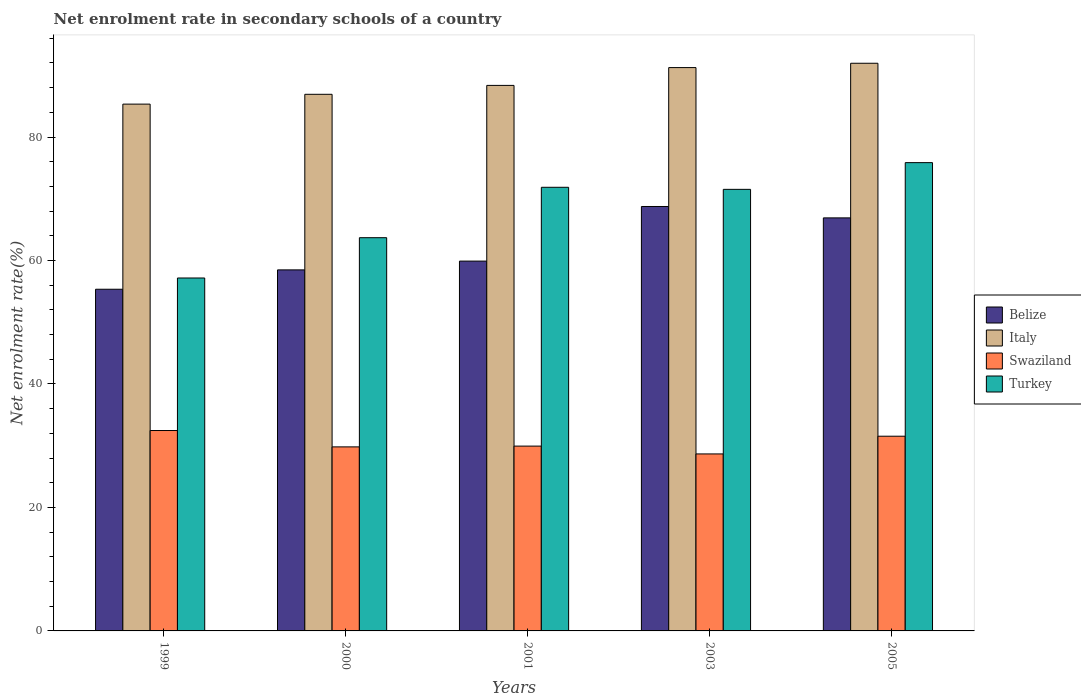How many different coloured bars are there?
Your answer should be very brief. 4. Are the number of bars on each tick of the X-axis equal?
Provide a succinct answer. Yes. How many bars are there on the 4th tick from the right?
Ensure brevity in your answer.  4. What is the label of the 5th group of bars from the left?
Offer a terse response. 2005. What is the net enrolment rate in secondary schools in Swaziland in 1999?
Offer a terse response. 32.46. Across all years, what is the maximum net enrolment rate in secondary schools in Italy?
Provide a succinct answer. 91.95. Across all years, what is the minimum net enrolment rate in secondary schools in Turkey?
Your answer should be compact. 57.17. What is the total net enrolment rate in secondary schools in Turkey in the graph?
Give a very brief answer. 340.11. What is the difference between the net enrolment rate in secondary schools in Swaziland in 1999 and that in 2003?
Offer a very short reply. 3.79. What is the difference between the net enrolment rate in secondary schools in Swaziland in 2000 and the net enrolment rate in secondary schools in Turkey in 2005?
Keep it short and to the point. -46.04. What is the average net enrolment rate in secondary schools in Turkey per year?
Give a very brief answer. 68.02. In the year 2001, what is the difference between the net enrolment rate in secondary schools in Belize and net enrolment rate in secondary schools in Swaziland?
Ensure brevity in your answer.  29.97. What is the ratio of the net enrolment rate in secondary schools in Belize in 1999 to that in 2001?
Provide a succinct answer. 0.92. Is the difference between the net enrolment rate in secondary schools in Belize in 1999 and 2001 greater than the difference between the net enrolment rate in secondary schools in Swaziland in 1999 and 2001?
Offer a very short reply. No. What is the difference between the highest and the second highest net enrolment rate in secondary schools in Turkey?
Offer a terse response. 3.99. What is the difference between the highest and the lowest net enrolment rate in secondary schools in Swaziland?
Your response must be concise. 3.79. Is it the case that in every year, the sum of the net enrolment rate in secondary schools in Swaziland and net enrolment rate in secondary schools in Belize is greater than the sum of net enrolment rate in secondary schools in Turkey and net enrolment rate in secondary schools in Italy?
Your answer should be compact. Yes. What does the 1st bar from the left in 2000 represents?
Offer a very short reply. Belize. What does the 1st bar from the right in 2003 represents?
Give a very brief answer. Turkey. How many bars are there?
Your answer should be compact. 20. Are all the bars in the graph horizontal?
Make the answer very short. No. What is the difference between two consecutive major ticks on the Y-axis?
Your answer should be very brief. 20. Does the graph contain any zero values?
Ensure brevity in your answer.  No. Does the graph contain grids?
Make the answer very short. No. Where does the legend appear in the graph?
Make the answer very short. Center right. How many legend labels are there?
Offer a very short reply. 4. What is the title of the graph?
Keep it short and to the point. Net enrolment rate in secondary schools of a country. What is the label or title of the Y-axis?
Make the answer very short. Net enrolment rate(%). What is the Net enrolment rate(%) of Belize in 1999?
Offer a terse response. 55.35. What is the Net enrolment rate(%) of Italy in 1999?
Your response must be concise. 85.33. What is the Net enrolment rate(%) of Swaziland in 1999?
Offer a terse response. 32.46. What is the Net enrolment rate(%) of Turkey in 1999?
Ensure brevity in your answer.  57.17. What is the Net enrolment rate(%) in Belize in 2000?
Offer a very short reply. 58.48. What is the Net enrolment rate(%) of Italy in 2000?
Offer a very short reply. 86.92. What is the Net enrolment rate(%) of Swaziland in 2000?
Give a very brief answer. 29.81. What is the Net enrolment rate(%) in Turkey in 2000?
Provide a succinct answer. 63.7. What is the Net enrolment rate(%) in Belize in 2001?
Keep it short and to the point. 59.9. What is the Net enrolment rate(%) in Italy in 2001?
Give a very brief answer. 88.37. What is the Net enrolment rate(%) in Swaziland in 2001?
Offer a terse response. 29.94. What is the Net enrolment rate(%) of Turkey in 2001?
Your response must be concise. 71.86. What is the Net enrolment rate(%) in Belize in 2003?
Your answer should be very brief. 68.75. What is the Net enrolment rate(%) in Italy in 2003?
Keep it short and to the point. 91.25. What is the Net enrolment rate(%) in Swaziland in 2003?
Provide a succinct answer. 28.67. What is the Net enrolment rate(%) of Turkey in 2003?
Provide a short and direct response. 71.53. What is the Net enrolment rate(%) of Belize in 2005?
Provide a succinct answer. 66.91. What is the Net enrolment rate(%) of Italy in 2005?
Provide a succinct answer. 91.95. What is the Net enrolment rate(%) of Swaziland in 2005?
Your answer should be compact. 31.54. What is the Net enrolment rate(%) of Turkey in 2005?
Ensure brevity in your answer.  75.85. Across all years, what is the maximum Net enrolment rate(%) of Belize?
Ensure brevity in your answer.  68.75. Across all years, what is the maximum Net enrolment rate(%) of Italy?
Your answer should be very brief. 91.95. Across all years, what is the maximum Net enrolment rate(%) in Swaziland?
Offer a very short reply. 32.46. Across all years, what is the maximum Net enrolment rate(%) of Turkey?
Your response must be concise. 75.85. Across all years, what is the minimum Net enrolment rate(%) in Belize?
Make the answer very short. 55.35. Across all years, what is the minimum Net enrolment rate(%) in Italy?
Give a very brief answer. 85.33. Across all years, what is the minimum Net enrolment rate(%) of Swaziland?
Ensure brevity in your answer.  28.67. Across all years, what is the minimum Net enrolment rate(%) in Turkey?
Offer a terse response. 57.17. What is the total Net enrolment rate(%) of Belize in the graph?
Keep it short and to the point. 309.39. What is the total Net enrolment rate(%) in Italy in the graph?
Give a very brief answer. 443.82. What is the total Net enrolment rate(%) in Swaziland in the graph?
Offer a very short reply. 152.42. What is the total Net enrolment rate(%) in Turkey in the graph?
Keep it short and to the point. 340.11. What is the difference between the Net enrolment rate(%) in Belize in 1999 and that in 2000?
Offer a very short reply. -3.14. What is the difference between the Net enrolment rate(%) in Italy in 1999 and that in 2000?
Ensure brevity in your answer.  -1.59. What is the difference between the Net enrolment rate(%) of Swaziland in 1999 and that in 2000?
Offer a very short reply. 2.65. What is the difference between the Net enrolment rate(%) of Turkey in 1999 and that in 2000?
Provide a succinct answer. -6.53. What is the difference between the Net enrolment rate(%) of Belize in 1999 and that in 2001?
Provide a short and direct response. -4.56. What is the difference between the Net enrolment rate(%) in Italy in 1999 and that in 2001?
Keep it short and to the point. -3.03. What is the difference between the Net enrolment rate(%) of Swaziland in 1999 and that in 2001?
Keep it short and to the point. 2.52. What is the difference between the Net enrolment rate(%) in Turkey in 1999 and that in 2001?
Your answer should be compact. -14.69. What is the difference between the Net enrolment rate(%) in Belize in 1999 and that in 2003?
Make the answer very short. -13.4. What is the difference between the Net enrolment rate(%) in Italy in 1999 and that in 2003?
Give a very brief answer. -5.92. What is the difference between the Net enrolment rate(%) of Swaziland in 1999 and that in 2003?
Your answer should be very brief. 3.79. What is the difference between the Net enrolment rate(%) in Turkey in 1999 and that in 2003?
Keep it short and to the point. -14.36. What is the difference between the Net enrolment rate(%) in Belize in 1999 and that in 2005?
Your answer should be very brief. -11.56. What is the difference between the Net enrolment rate(%) of Italy in 1999 and that in 2005?
Provide a succinct answer. -6.62. What is the difference between the Net enrolment rate(%) in Swaziland in 1999 and that in 2005?
Your response must be concise. 0.92. What is the difference between the Net enrolment rate(%) in Turkey in 1999 and that in 2005?
Make the answer very short. -18.69. What is the difference between the Net enrolment rate(%) of Belize in 2000 and that in 2001?
Ensure brevity in your answer.  -1.42. What is the difference between the Net enrolment rate(%) in Italy in 2000 and that in 2001?
Your answer should be very brief. -1.44. What is the difference between the Net enrolment rate(%) of Swaziland in 2000 and that in 2001?
Ensure brevity in your answer.  -0.13. What is the difference between the Net enrolment rate(%) of Turkey in 2000 and that in 2001?
Ensure brevity in your answer.  -8.17. What is the difference between the Net enrolment rate(%) in Belize in 2000 and that in 2003?
Keep it short and to the point. -10.27. What is the difference between the Net enrolment rate(%) in Italy in 2000 and that in 2003?
Ensure brevity in your answer.  -4.33. What is the difference between the Net enrolment rate(%) in Swaziland in 2000 and that in 2003?
Your response must be concise. 1.14. What is the difference between the Net enrolment rate(%) of Turkey in 2000 and that in 2003?
Provide a succinct answer. -7.83. What is the difference between the Net enrolment rate(%) of Belize in 2000 and that in 2005?
Ensure brevity in your answer.  -8.42. What is the difference between the Net enrolment rate(%) of Italy in 2000 and that in 2005?
Offer a very short reply. -5.03. What is the difference between the Net enrolment rate(%) in Swaziland in 2000 and that in 2005?
Your response must be concise. -1.73. What is the difference between the Net enrolment rate(%) in Turkey in 2000 and that in 2005?
Your answer should be very brief. -12.16. What is the difference between the Net enrolment rate(%) of Belize in 2001 and that in 2003?
Your answer should be compact. -8.85. What is the difference between the Net enrolment rate(%) in Italy in 2001 and that in 2003?
Offer a terse response. -2.89. What is the difference between the Net enrolment rate(%) of Swaziland in 2001 and that in 2003?
Keep it short and to the point. 1.27. What is the difference between the Net enrolment rate(%) in Turkey in 2001 and that in 2003?
Give a very brief answer. 0.34. What is the difference between the Net enrolment rate(%) of Belize in 2001 and that in 2005?
Offer a very short reply. -7. What is the difference between the Net enrolment rate(%) in Italy in 2001 and that in 2005?
Offer a very short reply. -3.59. What is the difference between the Net enrolment rate(%) of Swaziland in 2001 and that in 2005?
Make the answer very short. -1.6. What is the difference between the Net enrolment rate(%) of Turkey in 2001 and that in 2005?
Ensure brevity in your answer.  -3.99. What is the difference between the Net enrolment rate(%) in Belize in 2003 and that in 2005?
Your response must be concise. 1.84. What is the difference between the Net enrolment rate(%) in Italy in 2003 and that in 2005?
Your answer should be very brief. -0.7. What is the difference between the Net enrolment rate(%) in Swaziland in 2003 and that in 2005?
Your response must be concise. -2.87. What is the difference between the Net enrolment rate(%) of Turkey in 2003 and that in 2005?
Offer a terse response. -4.33. What is the difference between the Net enrolment rate(%) in Belize in 1999 and the Net enrolment rate(%) in Italy in 2000?
Keep it short and to the point. -31.58. What is the difference between the Net enrolment rate(%) in Belize in 1999 and the Net enrolment rate(%) in Swaziland in 2000?
Give a very brief answer. 25.54. What is the difference between the Net enrolment rate(%) in Belize in 1999 and the Net enrolment rate(%) in Turkey in 2000?
Make the answer very short. -8.35. What is the difference between the Net enrolment rate(%) of Italy in 1999 and the Net enrolment rate(%) of Swaziland in 2000?
Make the answer very short. 55.52. What is the difference between the Net enrolment rate(%) in Italy in 1999 and the Net enrolment rate(%) in Turkey in 2000?
Provide a short and direct response. 21.64. What is the difference between the Net enrolment rate(%) of Swaziland in 1999 and the Net enrolment rate(%) of Turkey in 2000?
Keep it short and to the point. -31.23. What is the difference between the Net enrolment rate(%) in Belize in 1999 and the Net enrolment rate(%) in Italy in 2001?
Keep it short and to the point. -33.02. What is the difference between the Net enrolment rate(%) in Belize in 1999 and the Net enrolment rate(%) in Swaziland in 2001?
Ensure brevity in your answer.  25.41. What is the difference between the Net enrolment rate(%) in Belize in 1999 and the Net enrolment rate(%) in Turkey in 2001?
Ensure brevity in your answer.  -16.52. What is the difference between the Net enrolment rate(%) in Italy in 1999 and the Net enrolment rate(%) in Swaziland in 2001?
Provide a succinct answer. 55.4. What is the difference between the Net enrolment rate(%) of Italy in 1999 and the Net enrolment rate(%) of Turkey in 2001?
Make the answer very short. 13.47. What is the difference between the Net enrolment rate(%) of Swaziland in 1999 and the Net enrolment rate(%) of Turkey in 2001?
Your answer should be compact. -39.4. What is the difference between the Net enrolment rate(%) of Belize in 1999 and the Net enrolment rate(%) of Italy in 2003?
Give a very brief answer. -35.91. What is the difference between the Net enrolment rate(%) in Belize in 1999 and the Net enrolment rate(%) in Swaziland in 2003?
Your answer should be compact. 26.68. What is the difference between the Net enrolment rate(%) in Belize in 1999 and the Net enrolment rate(%) in Turkey in 2003?
Make the answer very short. -16.18. What is the difference between the Net enrolment rate(%) in Italy in 1999 and the Net enrolment rate(%) in Swaziland in 2003?
Your response must be concise. 56.66. What is the difference between the Net enrolment rate(%) of Italy in 1999 and the Net enrolment rate(%) of Turkey in 2003?
Make the answer very short. 13.81. What is the difference between the Net enrolment rate(%) of Swaziland in 1999 and the Net enrolment rate(%) of Turkey in 2003?
Give a very brief answer. -39.06. What is the difference between the Net enrolment rate(%) of Belize in 1999 and the Net enrolment rate(%) of Italy in 2005?
Your response must be concise. -36.61. What is the difference between the Net enrolment rate(%) of Belize in 1999 and the Net enrolment rate(%) of Swaziland in 2005?
Give a very brief answer. 23.81. What is the difference between the Net enrolment rate(%) of Belize in 1999 and the Net enrolment rate(%) of Turkey in 2005?
Your answer should be very brief. -20.51. What is the difference between the Net enrolment rate(%) of Italy in 1999 and the Net enrolment rate(%) of Swaziland in 2005?
Provide a succinct answer. 53.79. What is the difference between the Net enrolment rate(%) in Italy in 1999 and the Net enrolment rate(%) in Turkey in 2005?
Offer a very short reply. 9.48. What is the difference between the Net enrolment rate(%) of Swaziland in 1999 and the Net enrolment rate(%) of Turkey in 2005?
Give a very brief answer. -43.39. What is the difference between the Net enrolment rate(%) in Belize in 2000 and the Net enrolment rate(%) in Italy in 2001?
Ensure brevity in your answer.  -29.88. What is the difference between the Net enrolment rate(%) in Belize in 2000 and the Net enrolment rate(%) in Swaziland in 2001?
Ensure brevity in your answer.  28.55. What is the difference between the Net enrolment rate(%) in Belize in 2000 and the Net enrolment rate(%) in Turkey in 2001?
Your answer should be compact. -13.38. What is the difference between the Net enrolment rate(%) of Italy in 2000 and the Net enrolment rate(%) of Swaziland in 2001?
Offer a very short reply. 56.99. What is the difference between the Net enrolment rate(%) in Italy in 2000 and the Net enrolment rate(%) in Turkey in 2001?
Keep it short and to the point. 15.06. What is the difference between the Net enrolment rate(%) in Swaziland in 2000 and the Net enrolment rate(%) in Turkey in 2001?
Your response must be concise. -42.05. What is the difference between the Net enrolment rate(%) of Belize in 2000 and the Net enrolment rate(%) of Italy in 2003?
Make the answer very short. -32.77. What is the difference between the Net enrolment rate(%) of Belize in 2000 and the Net enrolment rate(%) of Swaziland in 2003?
Your answer should be compact. 29.81. What is the difference between the Net enrolment rate(%) in Belize in 2000 and the Net enrolment rate(%) in Turkey in 2003?
Ensure brevity in your answer.  -13.04. What is the difference between the Net enrolment rate(%) of Italy in 2000 and the Net enrolment rate(%) of Swaziland in 2003?
Provide a succinct answer. 58.25. What is the difference between the Net enrolment rate(%) in Italy in 2000 and the Net enrolment rate(%) in Turkey in 2003?
Make the answer very short. 15.4. What is the difference between the Net enrolment rate(%) of Swaziland in 2000 and the Net enrolment rate(%) of Turkey in 2003?
Your answer should be very brief. -41.72. What is the difference between the Net enrolment rate(%) of Belize in 2000 and the Net enrolment rate(%) of Italy in 2005?
Ensure brevity in your answer.  -33.47. What is the difference between the Net enrolment rate(%) in Belize in 2000 and the Net enrolment rate(%) in Swaziland in 2005?
Make the answer very short. 26.94. What is the difference between the Net enrolment rate(%) in Belize in 2000 and the Net enrolment rate(%) in Turkey in 2005?
Ensure brevity in your answer.  -17.37. What is the difference between the Net enrolment rate(%) in Italy in 2000 and the Net enrolment rate(%) in Swaziland in 2005?
Offer a terse response. 55.38. What is the difference between the Net enrolment rate(%) in Italy in 2000 and the Net enrolment rate(%) in Turkey in 2005?
Your answer should be very brief. 11.07. What is the difference between the Net enrolment rate(%) of Swaziland in 2000 and the Net enrolment rate(%) of Turkey in 2005?
Ensure brevity in your answer.  -46.04. What is the difference between the Net enrolment rate(%) of Belize in 2001 and the Net enrolment rate(%) of Italy in 2003?
Provide a short and direct response. -31.35. What is the difference between the Net enrolment rate(%) in Belize in 2001 and the Net enrolment rate(%) in Swaziland in 2003?
Provide a short and direct response. 31.23. What is the difference between the Net enrolment rate(%) in Belize in 2001 and the Net enrolment rate(%) in Turkey in 2003?
Offer a terse response. -11.62. What is the difference between the Net enrolment rate(%) of Italy in 2001 and the Net enrolment rate(%) of Swaziland in 2003?
Your answer should be very brief. 59.69. What is the difference between the Net enrolment rate(%) of Italy in 2001 and the Net enrolment rate(%) of Turkey in 2003?
Provide a short and direct response. 16.84. What is the difference between the Net enrolment rate(%) in Swaziland in 2001 and the Net enrolment rate(%) in Turkey in 2003?
Keep it short and to the point. -41.59. What is the difference between the Net enrolment rate(%) in Belize in 2001 and the Net enrolment rate(%) in Italy in 2005?
Give a very brief answer. -32.05. What is the difference between the Net enrolment rate(%) of Belize in 2001 and the Net enrolment rate(%) of Swaziland in 2005?
Ensure brevity in your answer.  28.37. What is the difference between the Net enrolment rate(%) in Belize in 2001 and the Net enrolment rate(%) in Turkey in 2005?
Offer a very short reply. -15.95. What is the difference between the Net enrolment rate(%) of Italy in 2001 and the Net enrolment rate(%) of Swaziland in 2005?
Provide a short and direct response. 56.83. What is the difference between the Net enrolment rate(%) of Italy in 2001 and the Net enrolment rate(%) of Turkey in 2005?
Offer a terse response. 12.51. What is the difference between the Net enrolment rate(%) in Swaziland in 2001 and the Net enrolment rate(%) in Turkey in 2005?
Offer a terse response. -45.92. What is the difference between the Net enrolment rate(%) in Belize in 2003 and the Net enrolment rate(%) in Italy in 2005?
Offer a terse response. -23.2. What is the difference between the Net enrolment rate(%) of Belize in 2003 and the Net enrolment rate(%) of Swaziland in 2005?
Keep it short and to the point. 37.21. What is the difference between the Net enrolment rate(%) in Belize in 2003 and the Net enrolment rate(%) in Turkey in 2005?
Your response must be concise. -7.1. What is the difference between the Net enrolment rate(%) of Italy in 2003 and the Net enrolment rate(%) of Swaziland in 2005?
Make the answer very short. 59.71. What is the difference between the Net enrolment rate(%) in Italy in 2003 and the Net enrolment rate(%) in Turkey in 2005?
Give a very brief answer. 15.4. What is the difference between the Net enrolment rate(%) of Swaziland in 2003 and the Net enrolment rate(%) of Turkey in 2005?
Your answer should be compact. -47.18. What is the average Net enrolment rate(%) of Belize per year?
Your answer should be compact. 61.88. What is the average Net enrolment rate(%) in Italy per year?
Ensure brevity in your answer.  88.76. What is the average Net enrolment rate(%) in Swaziland per year?
Make the answer very short. 30.48. What is the average Net enrolment rate(%) of Turkey per year?
Offer a very short reply. 68.02. In the year 1999, what is the difference between the Net enrolment rate(%) of Belize and Net enrolment rate(%) of Italy?
Provide a succinct answer. -29.99. In the year 1999, what is the difference between the Net enrolment rate(%) in Belize and Net enrolment rate(%) in Swaziland?
Provide a short and direct response. 22.88. In the year 1999, what is the difference between the Net enrolment rate(%) of Belize and Net enrolment rate(%) of Turkey?
Make the answer very short. -1.82. In the year 1999, what is the difference between the Net enrolment rate(%) in Italy and Net enrolment rate(%) in Swaziland?
Keep it short and to the point. 52.87. In the year 1999, what is the difference between the Net enrolment rate(%) in Italy and Net enrolment rate(%) in Turkey?
Ensure brevity in your answer.  28.16. In the year 1999, what is the difference between the Net enrolment rate(%) in Swaziland and Net enrolment rate(%) in Turkey?
Your answer should be compact. -24.71. In the year 2000, what is the difference between the Net enrolment rate(%) in Belize and Net enrolment rate(%) in Italy?
Offer a terse response. -28.44. In the year 2000, what is the difference between the Net enrolment rate(%) in Belize and Net enrolment rate(%) in Swaziland?
Give a very brief answer. 28.67. In the year 2000, what is the difference between the Net enrolment rate(%) of Belize and Net enrolment rate(%) of Turkey?
Your answer should be very brief. -5.21. In the year 2000, what is the difference between the Net enrolment rate(%) of Italy and Net enrolment rate(%) of Swaziland?
Your answer should be very brief. 57.11. In the year 2000, what is the difference between the Net enrolment rate(%) of Italy and Net enrolment rate(%) of Turkey?
Ensure brevity in your answer.  23.23. In the year 2000, what is the difference between the Net enrolment rate(%) in Swaziland and Net enrolment rate(%) in Turkey?
Your answer should be compact. -33.89. In the year 2001, what is the difference between the Net enrolment rate(%) in Belize and Net enrolment rate(%) in Italy?
Your answer should be very brief. -28.46. In the year 2001, what is the difference between the Net enrolment rate(%) of Belize and Net enrolment rate(%) of Swaziland?
Keep it short and to the point. 29.97. In the year 2001, what is the difference between the Net enrolment rate(%) of Belize and Net enrolment rate(%) of Turkey?
Provide a succinct answer. -11.96. In the year 2001, what is the difference between the Net enrolment rate(%) in Italy and Net enrolment rate(%) in Swaziland?
Make the answer very short. 58.43. In the year 2001, what is the difference between the Net enrolment rate(%) in Italy and Net enrolment rate(%) in Turkey?
Provide a short and direct response. 16.5. In the year 2001, what is the difference between the Net enrolment rate(%) of Swaziland and Net enrolment rate(%) of Turkey?
Your answer should be very brief. -41.92. In the year 2003, what is the difference between the Net enrolment rate(%) of Belize and Net enrolment rate(%) of Italy?
Your answer should be compact. -22.5. In the year 2003, what is the difference between the Net enrolment rate(%) in Belize and Net enrolment rate(%) in Swaziland?
Keep it short and to the point. 40.08. In the year 2003, what is the difference between the Net enrolment rate(%) of Belize and Net enrolment rate(%) of Turkey?
Provide a succinct answer. -2.78. In the year 2003, what is the difference between the Net enrolment rate(%) in Italy and Net enrolment rate(%) in Swaziland?
Give a very brief answer. 62.58. In the year 2003, what is the difference between the Net enrolment rate(%) of Italy and Net enrolment rate(%) of Turkey?
Keep it short and to the point. 19.73. In the year 2003, what is the difference between the Net enrolment rate(%) in Swaziland and Net enrolment rate(%) in Turkey?
Keep it short and to the point. -42.86. In the year 2005, what is the difference between the Net enrolment rate(%) in Belize and Net enrolment rate(%) in Italy?
Give a very brief answer. -25.05. In the year 2005, what is the difference between the Net enrolment rate(%) in Belize and Net enrolment rate(%) in Swaziland?
Ensure brevity in your answer.  35.37. In the year 2005, what is the difference between the Net enrolment rate(%) of Belize and Net enrolment rate(%) of Turkey?
Ensure brevity in your answer.  -8.95. In the year 2005, what is the difference between the Net enrolment rate(%) in Italy and Net enrolment rate(%) in Swaziland?
Your response must be concise. 60.41. In the year 2005, what is the difference between the Net enrolment rate(%) in Italy and Net enrolment rate(%) in Turkey?
Your answer should be very brief. 16.1. In the year 2005, what is the difference between the Net enrolment rate(%) in Swaziland and Net enrolment rate(%) in Turkey?
Provide a succinct answer. -44.32. What is the ratio of the Net enrolment rate(%) in Belize in 1999 to that in 2000?
Offer a terse response. 0.95. What is the ratio of the Net enrolment rate(%) of Italy in 1999 to that in 2000?
Provide a short and direct response. 0.98. What is the ratio of the Net enrolment rate(%) in Swaziland in 1999 to that in 2000?
Offer a very short reply. 1.09. What is the ratio of the Net enrolment rate(%) in Turkey in 1999 to that in 2000?
Your answer should be very brief. 0.9. What is the ratio of the Net enrolment rate(%) of Belize in 1999 to that in 2001?
Keep it short and to the point. 0.92. What is the ratio of the Net enrolment rate(%) of Italy in 1999 to that in 2001?
Offer a terse response. 0.97. What is the ratio of the Net enrolment rate(%) in Swaziland in 1999 to that in 2001?
Provide a short and direct response. 1.08. What is the ratio of the Net enrolment rate(%) in Turkey in 1999 to that in 2001?
Provide a short and direct response. 0.8. What is the ratio of the Net enrolment rate(%) of Belize in 1999 to that in 2003?
Provide a succinct answer. 0.81. What is the ratio of the Net enrolment rate(%) of Italy in 1999 to that in 2003?
Your answer should be compact. 0.94. What is the ratio of the Net enrolment rate(%) of Swaziland in 1999 to that in 2003?
Ensure brevity in your answer.  1.13. What is the ratio of the Net enrolment rate(%) in Turkey in 1999 to that in 2003?
Offer a terse response. 0.8. What is the ratio of the Net enrolment rate(%) in Belize in 1999 to that in 2005?
Your answer should be very brief. 0.83. What is the ratio of the Net enrolment rate(%) of Italy in 1999 to that in 2005?
Give a very brief answer. 0.93. What is the ratio of the Net enrolment rate(%) in Swaziland in 1999 to that in 2005?
Your response must be concise. 1.03. What is the ratio of the Net enrolment rate(%) of Turkey in 1999 to that in 2005?
Ensure brevity in your answer.  0.75. What is the ratio of the Net enrolment rate(%) of Belize in 2000 to that in 2001?
Make the answer very short. 0.98. What is the ratio of the Net enrolment rate(%) in Italy in 2000 to that in 2001?
Your answer should be very brief. 0.98. What is the ratio of the Net enrolment rate(%) in Turkey in 2000 to that in 2001?
Offer a very short reply. 0.89. What is the ratio of the Net enrolment rate(%) of Belize in 2000 to that in 2003?
Your answer should be very brief. 0.85. What is the ratio of the Net enrolment rate(%) in Italy in 2000 to that in 2003?
Give a very brief answer. 0.95. What is the ratio of the Net enrolment rate(%) of Swaziland in 2000 to that in 2003?
Your response must be concise. 1.04. What is the ratio of the Net enrolment rate(%) in Turkey in 2000 to that in 2003?
Offer a very short reply. 0.89. What is the ratio of the Net enrolment rate(%) in Belize in 2000 to that in 2005?
Give a very brief answer. 0.87. What is the ratio of the Net enrolment rate(%) of Italy in 2000 to that in 2005?
Keep it short and to the point. 0.95. What is the ratio of the Net enrolment rate(%) in Swaziland in 2000 to that in 2005?
Ensure brevity in your answer.  0.95. What is the ratio of the Net enrolment rate(%) in Turkey in 2000 to that in 2005?
Offer a very short reply. 0.84. What is the ratio of the Net enrolment rate(%) in Belize in 2001 to that in 2003?
Your answer should be compact. 0.87. What is the ratio of the Net enrolment rate(%) of Italy in 2001 to that in 2003?
Your answer should be compact. 0.97. What is the ratio of the Net enrolment rate(%) in Swaziland in 2001 to that in 2003?
Your answer should be compact. 1.04. What is the ratio of the Net enrolment rate(%) of Turkey in 2001 to that in 2003?
Give a very brief answer. 1. What is the ratio of the Net enrolment rate(%) of Belize in 2001 to that in 2005?
Your answer should be very brief. 0.9. What is the ratio of the Net enrolment rate(%) in Swaziland in 2001 to that in 2005?
Provide a short and direct response. 0.95. What is the ratio of the Net enrolment rate(%) of Belize in 2003 to that in 2005?
Provide a short and direct response. 1.03. What is the ratio of the Net enrolment rate(%) in Swaziland in 2003 to that in 2005?
Your response must be concise. 0.91. What is the ratio of the Net enrolment rate(%) of Turkey in 2003 to that in 2005?
Ensure brevity in your answer.  0.94. What is the difference between the highest and the second highest Net enrolment rate(%) in Belize?
Offer a terse response. 1.84. What is the difference between the highest and the second highest Net enrolment rate(%) in Italy?
Give a very brief answer. 0.7. What is the difference between the highest and the second highest Net enrolment rate(%) of Swaziland?
Keep it short and to the point. 0.92. What is the difference between the highest and the second highest Net enrolment rate(%) of Turkey?
Your response must be concise. 3.99. What is the difference between the highest and the lowest Net enrolment rate(%) in Belize?
Keep it short and to the point. 13.4. What is the difference between the highest and the lowest Net enrolment rate(%) in Italy?
Offer a terse response. 6.62. What is the difference between the highest and the lowest Net enrolment rate(%) in Swaziland?
Ensure brevity in your answer.  3.79. What is the difference between the highest and the lowest Net enrolment rate(%) of Turkey?
Keep it short and to the point. 18.69. 